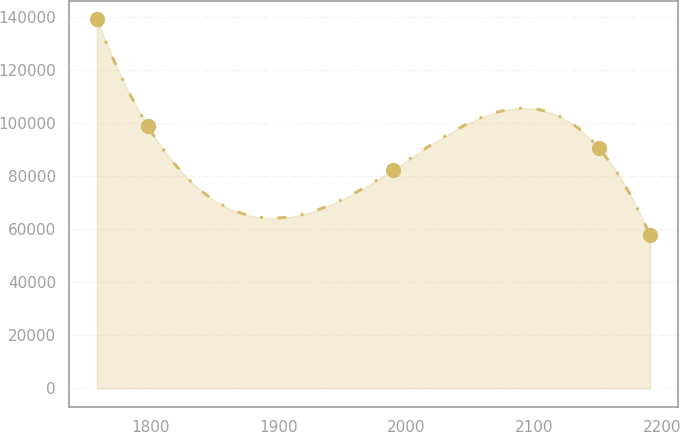<chart> <loc_0><loc_0><loc_500><loc_500><line_chart><ecel><fcel>Unnamed: 1<nl><fcel>1758.35<fcel>139146<nl><fcel>1798.36<fcel>98724.2<nl><fcel>1989.8<fcel>82346.9<nl><fcel>2150.52<fcel>90495<nl><fcel>2190.53<fcel>57664.4<nl></chart> 